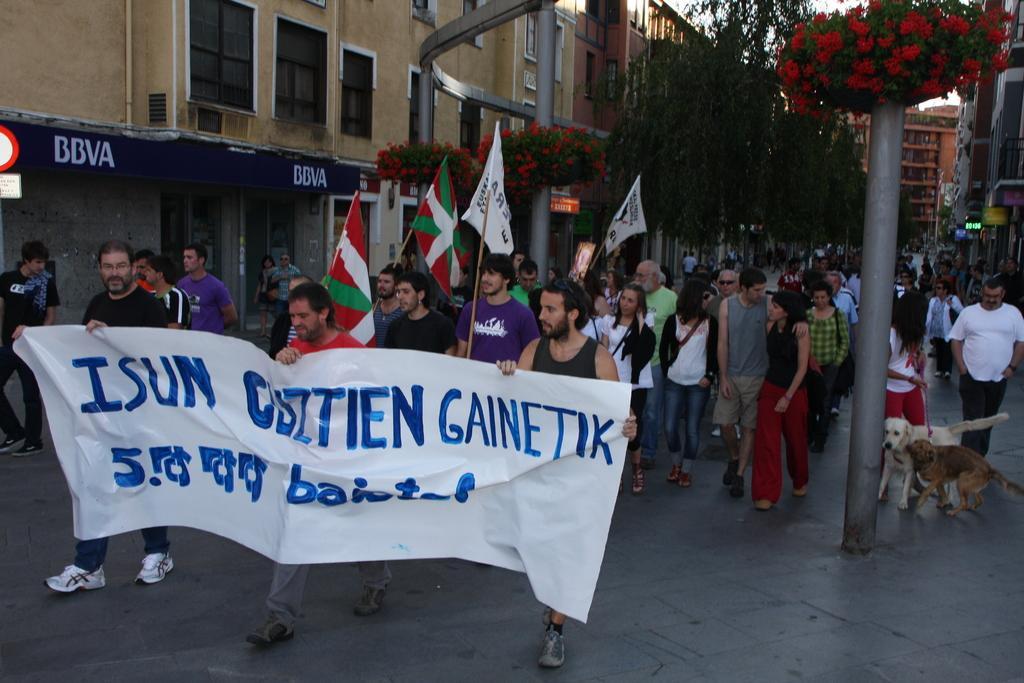How would you summarize this image in a sentence or two? In this image we can see some people in the street and among them few people holding a banner and there is some text on it and few people holding flags. There are some buildings and we can see some trees and flowers and there are two dogs on the right side of the image and we can see the sky. 